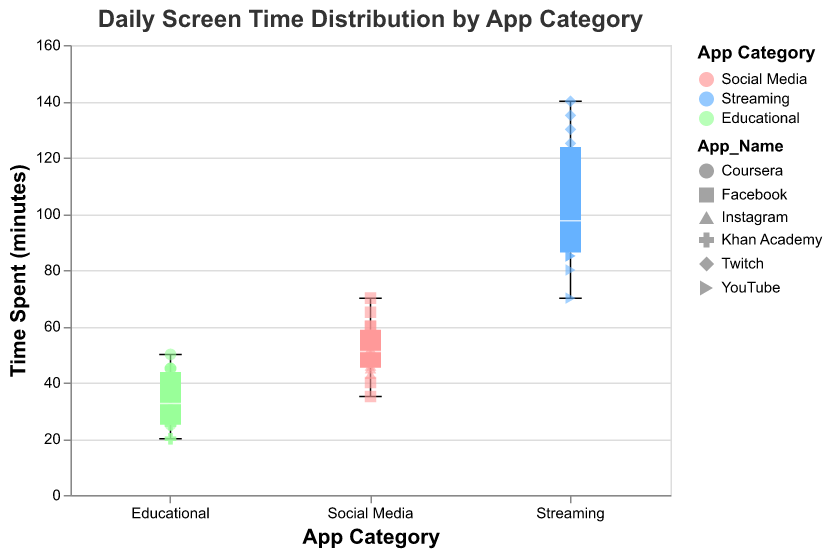Which app category has the highest median screen time? The median screen time is represented by the white line in the middle of each boxplot. The Streaming category has the highest median screen time compared to Social Media and Educational apps.
Answer: Streaming What is the range of screen time for the Social Media category? The range of screen time in a boxplot can be identified from the minimum to the maximum values indicated by the whiskers. For Social Media, the values range from the lowest spent time (35 minutes) to the highest spent time (70 minutes).
Answer: 35-70 minutes Which app category shows the most variability in screen time? The variability in screen time is represented by the length of the box and the whiskers. The Streaming category shows the box with the longest whiskers stretching from minimum to maximum, indicating it has the most variability in screen time.
Answer: Streaming What's the highest screen time recorded for any streaming app, and which app does it correspond to? The highest screen time recorded is represented by the highest point on the plot. For Streaming, the highest point is at 140 minutes, which corresponds to Twitch.
Answer: 140 minutes, Twitch How does the median screen time of Educational apps compare to Social Media apps? The median for Educational apps and Social Media apps is indicated by the white lines in the middle of their respective boxes. The median screen time for Educational apps is lower than that of Social Media apps.
Answer: Lower Which app under the Social Media category has the highest screen time and what is its value? Look for the highest point within the Social Media category scatter points. The highest screen time for Social Media is recorded by Facebook, which is 70 minutes.
Answer: Facebook, 70 minutes What's the interquartile range (IQR) for screen time in the Educational apps category? The IQR is the range between the 75th percentile (top edge of the box) and the 25th percentile (bottom edge of the box). For Educational apps, the IQR is from 25 to 45 minutes.
Answer: 20 minutes 